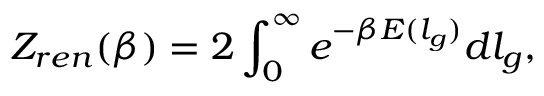Convert formula to latex. <formula><loc_0><loc_0><loc_500><loc_500>Z _ { r e n } ( \beta ) = 2 \int _ { 0 } ^ { \infty } e ^ { - \beta E ( l _ { g } ) } d l _ { g } ,</formula> 